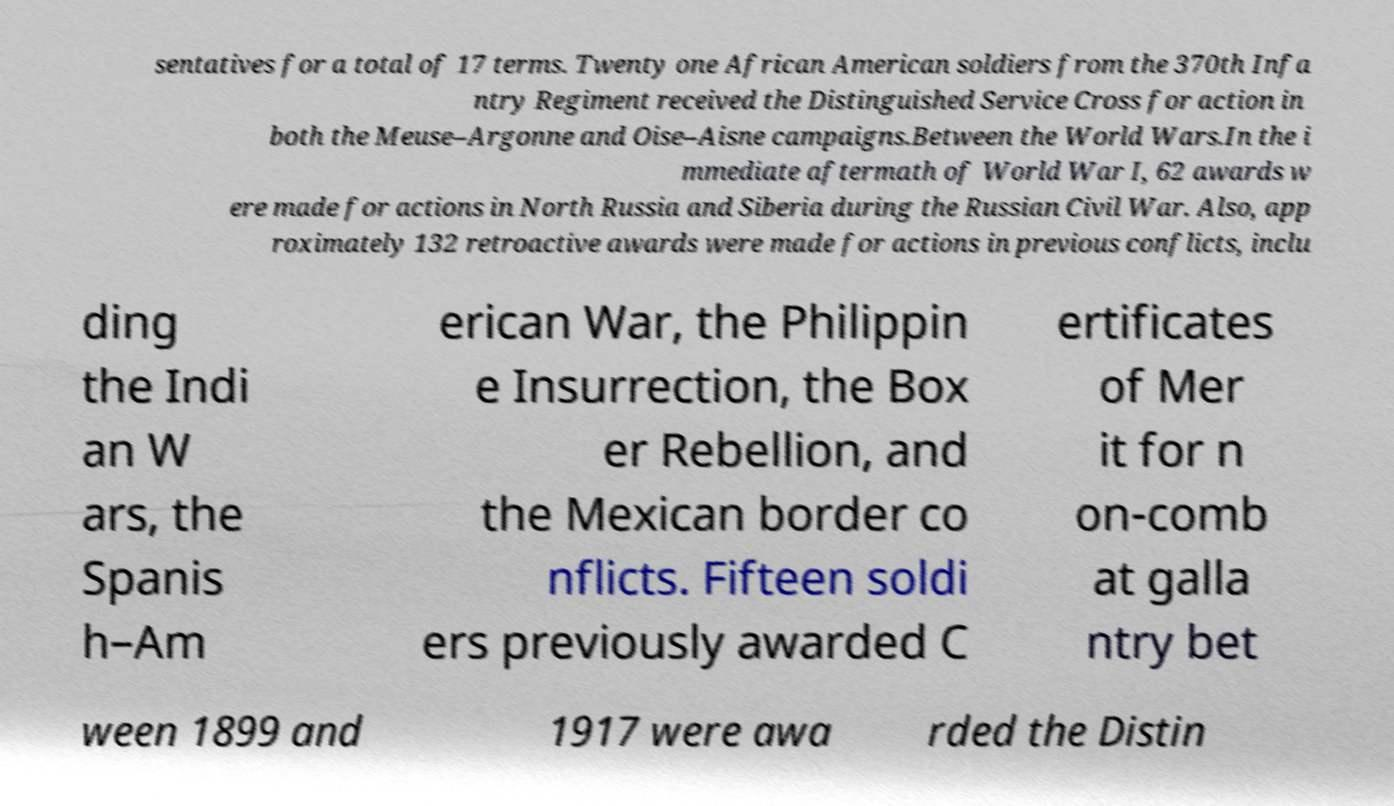Could you assist in decoding the text presented in this image and type it out clearly? sentatives for a total of 17 terms. Twenty one African American soldiers from the 370th Infa ntry Regiment received the Distinguished Service Cross for action in both the Meuse–Argonne and Oise–Aisne campaigns.Between the World Wars.In the i mmediate aftermath of World War I, 62 awards w ere made for actions in North Russia and Siberia during the Russian Civil War. Also, app roximately 132 retroactive awards were made for actions in previous conflicts, inclu ding the Indi an W ars, the Spanis h–Am erican War, the Philippin e Insurrection, the Box er Rebellion, and the Mexican border co nflicts. Fifteen soldi ers previously awarded C ertificates of Mer it for n on-comb at galla ntry bet ween 1899 and 1917 were awa rded the Distin 